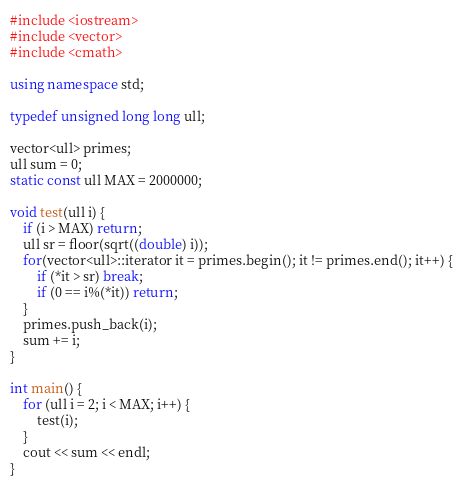Convert code to text. <code><loc_0><loc_0><loc_500><loc_500><_C++_>#include <iostream>
#include <vector>
#include <cmath>

using namespace std;

typedef unsigned long long ull;

vector<ull> primes;
ull sum = 0;
static const ull MAX = 2000000;

void test(ull i) {
    if (i > MAX) return;
    ull sr = floor(sqrt((double) i));
    for(vector<ull>::iterator it = primes.begin(); it != primes.end(); it++) {
        if (*it > sr) break;
        if (0 == i%(*it)) return;
    }
    primes.push_back(i);
    sum += i;
}

int main() {
    for (ull i = 2; i < MAX; i++) {
        test(i);
    }
    cout << sum << endl;
}
</code> 